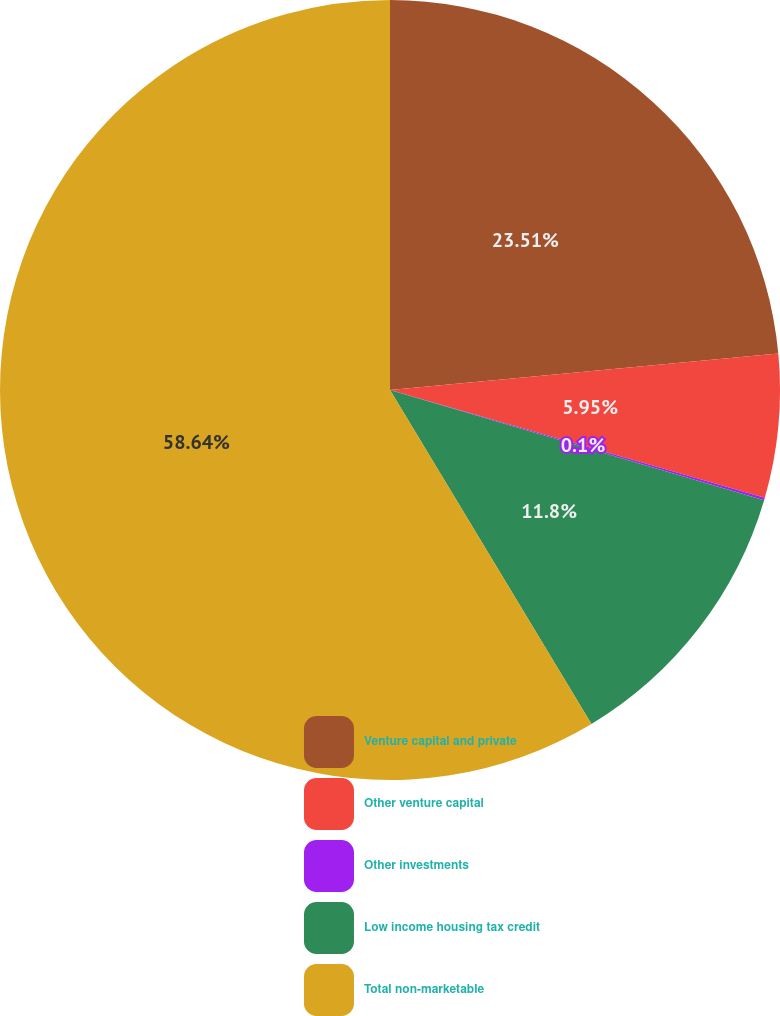Convert chart. <chart><loc_0><loc_0><loc_500><loc_500><pie_chart><fcel>Venture capital and private<fcel>Other venture capital<fcel>Other investments<fcel>Low income housing tax credit<fcel>Total non-marketable<nl><fcel>23.51%<fcel>5.95%<fcel>0.1%<fcel>11.8%<fcel>58.64%<nl></chart> 